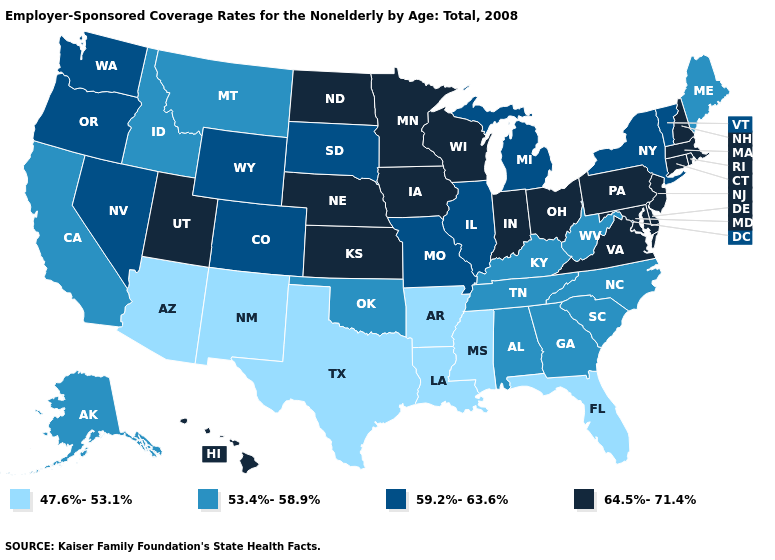Which states have the lowest value in the USA?
Be succinct. Arizona, Arkansas, Florida, Louisiana, Mississippi, New Mexico, Texas. Which states have the lowest value in the USA?
Quick response, please. Arizona, Arkansas, Florida, Louisiana, Mississippi, New Mexico, Texas. Does the map have missing data?
Keep it brief. No. Does Illinois have the same value as Mississippi?
Short answer required. No. What is the value of Mississippi?
Concise answer only. 47.6%-53.1%. What is the highest value in states that border Idaho?
Concise answer only. 64.5%-71.4%. Name the states that have a value in the range 53.4%-58.9%?
Keep it brief. Alabama, Alaska, California, Georgia, Idaho, Kentucky, Maine, Montana, North Carolina, Oklahoma, South Carolina, Tennessee, West Virginia. What is the highest value in the USA?
Write a very short answer. 64.5%-71.4%. How many symbols are there in the legend?
Short answer required. 4. Is the legend a continuous bar?
Answer briefly. No. What is the lowest value in the West?
Keep it brief. 47.6%-53.1%. What is the highest value in the Northeast ?
Concise answer only. 64.5%-71.4%. Does Delaware have a lower value than Ohio?
Quick response, please. No. Among the states that border Nevada , does Utah have the highest value?
Write a very short answer. Yes. What is the value of Mississippi?
Keep it brief. 47.6%-53.1%. 